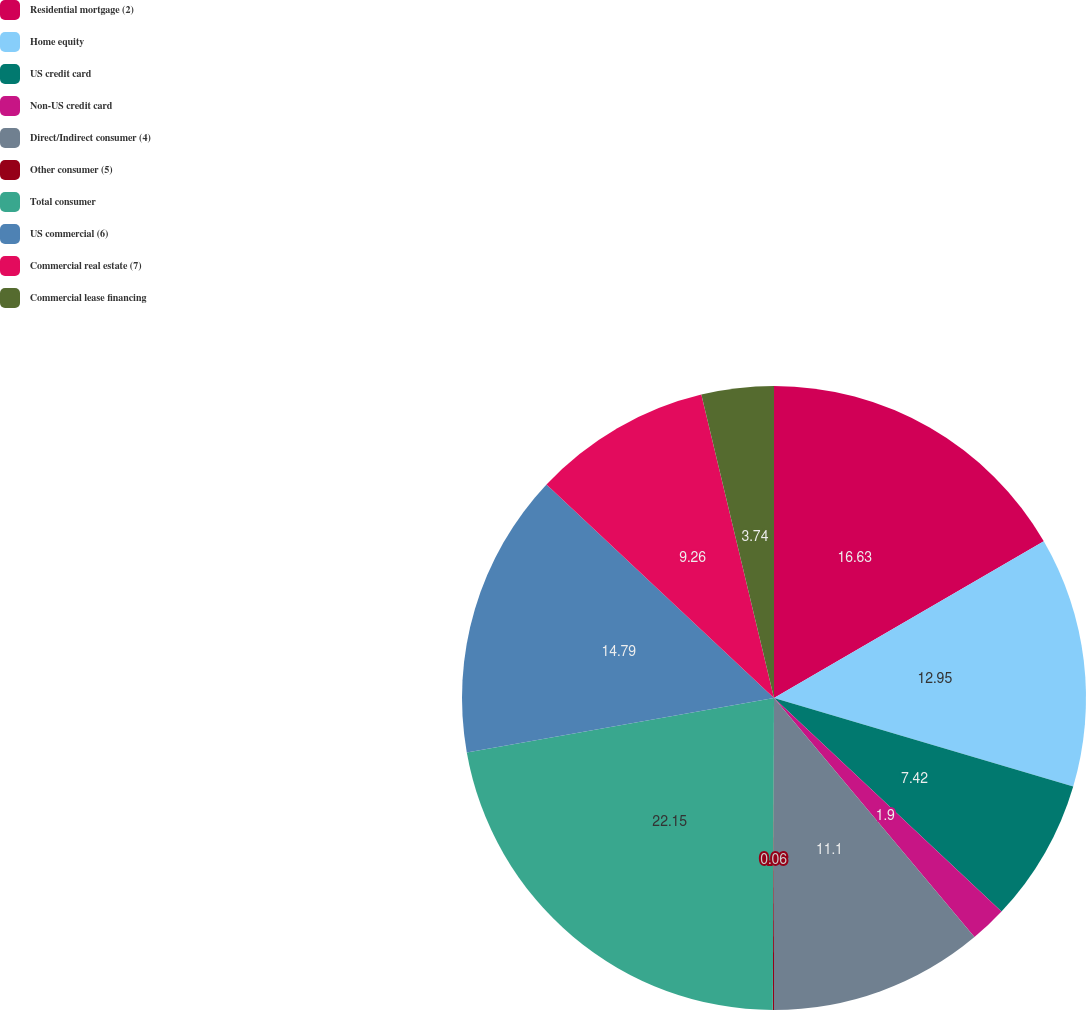Convert chart. <chart><loc_0><loc_0><loc_500><loc_500><pie_chart><fcel>Residential mortgage (2)<fcel>Home equity<fcel>US credit card<fcel>Non-US credit card<fcel>Direct/Indirect consumer (4)<fcel>Other consumer (5)<fcel>Total consumer<fcel>US commercial (6)<fcel>Commercial real estate (7)<fcel>Commercial lease financing<nl><fcel>16.62%<fcel>12.94%<fcel>7.42%<fcel>1.9%<fcel>11.1%<fcel>0.06%<fcel>22.14%<fcel>14.78%<fcel>9.26%<fcel>3.74%<nl></chart> 